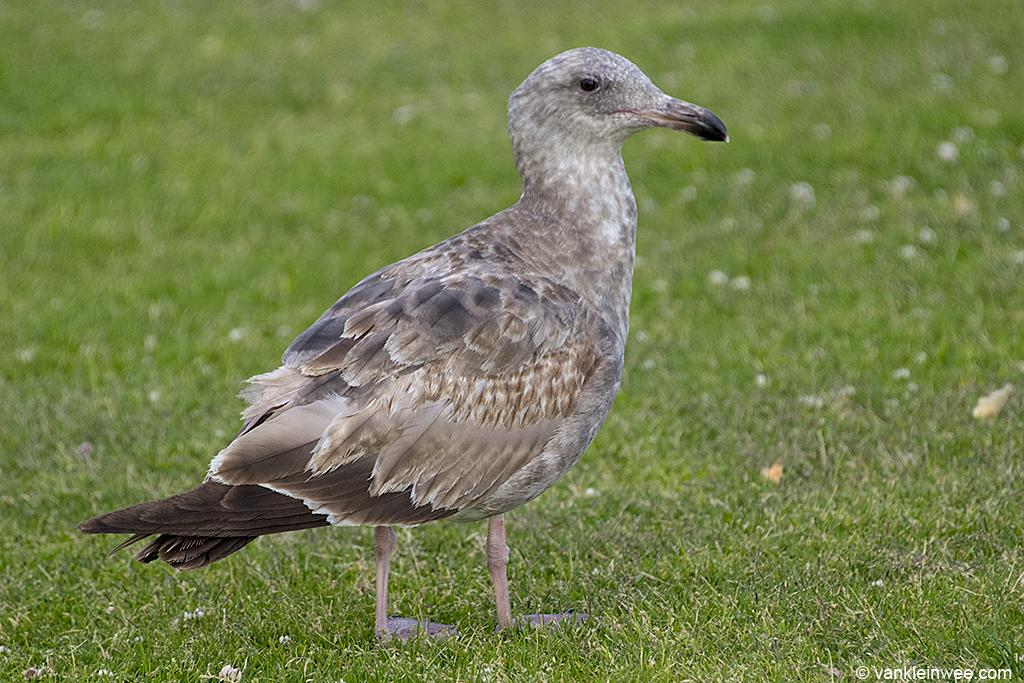What is the main subject in the foreground of the image? There is a bird in the foreground of the image. What is the bird standing on? The bird is standing on the grass. Can you describe the time of day when the image was likely taken? The image was likely taken during the day. From what perspective was the image likely taken? The image was likely taken from the ground level. What type of crown is the bird wearing in the image? There is no crown present in the image; the bird is not wearing any accessories. 